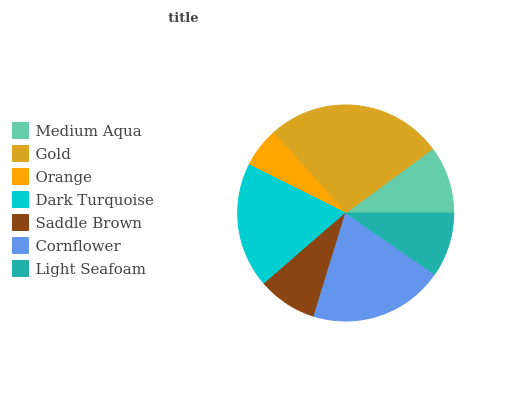Is Orange the minimum?
Answer yes or no. Yes. Is Gold the maximum?
Answer yes or no. Yes. Is Gold the minimum?
Answer yes or no. No. Is Orange the maximum?
Answer yes or no. No. Is Gold greater than Orange?
Answer yes or no. Yes. Is Orange less than Gold?
Answer yes or no. Yes. Is Orange greater than Gold?
Answer yes or no. No. Is Gold less than Orange?
Answer yes or no. No. Is Medium Aqua the high median?
Answer yes or no. Yes. Is Medium Aqua the low median?
Answer yes or no. Yes. Is Cornflower the high median?
Answer yes or no. No. Is Light Seafoam the low median?
Answer yes or no. No. 